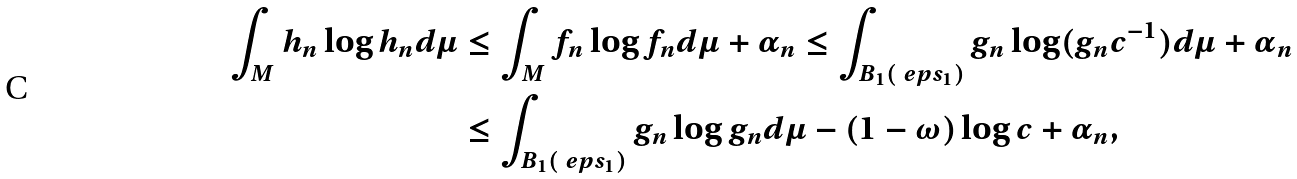Convert formula to latex. <formula><loc_0><loc_0><loc_500><loc_500>\int _ { M } h _ { n } \log h _ { n } d \mu & \leq \int _ { M } f _ { n } \log f _ { n } d \mu + \alpha _ { n } \leq \int _ { B _ { 1 } ( \ e p s _ { 1 } ) } g _ { n } \log ( g _ { n } c ^ { - 1 } ) d \mu + \alpha _ { n } \\ & \leq \int _ { B _ { 1 } ( \ e p s _ { 1 } ) } g _ { n } \log g _ { n } d \mu - ( 1 - \omega ) \log c + \alpha _ { n } ,</formula> 